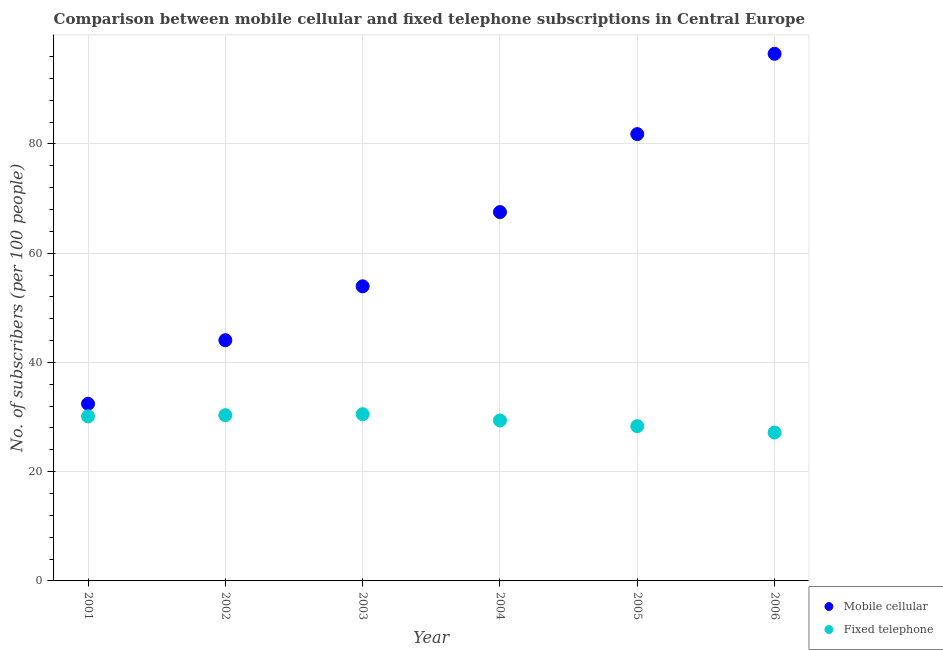Is the number of dotlines equal to the number of legend labels?
Offer a terse response. Yes. What is the number of fixed telephone subscribers in 2001?
Give a very brief answer. 30.13. Across all years, what is the maximum number of mobile cellular subscribers?
Your answer should be compact. 96.49. Across all years, what is the minimum number of fixed telephone subscribers?
Your answer should be compact. 27.16. In which year was the number of fixed telephone subscribers maximum?
Offer a terse response. 2003. In which year was the number of mobile cellular subscribers minimum?
Your answer should be very brief. 2001. What is the total number of fixed telephone subscribers in the graph?
Give a very brief answer. 175.86. What is the difference between the number of mobile cellular subscribers in 2001 and that in 2002?
Your answer should be compact. -11.64. What is the difference between the number of fixed telephone subscribers in 2001 and the number of mobile cellular subscribers in 2006?
Provide a succinct answer. -66.36. What is the average number of mobile cellular subscribers per year?
Provide a short and direct response. 62.71. In the year 2005, what is the difference between the number of fixed telephone subscribers and number of mobile cellular subscribers?
Make the answer very short. -53.47. What is the ratio of the number of mobile cellular subscribers in 2003 to that in 2004?
Ensure brevity in your answer.  0.8. Is the number of fixed telephone subscribers in 2002 less than that in 2004?
Keep it short and to the point. No. Is the difference between the number of mobile cellular subscribers in 2001 and 2005 greater than the difference between the number of fixed telephone subscribers in 2001 and 2005?
Your response must be concise. No. What is the difference between the highest and the second highest number of fixed telephone subscribers?
Offer a terse response. 0.18. What is the difference between the highest and the lowest number of fixed telephone subscribers?
Give a very brief answer. 3.36. In how many years, is the number of mobile cellular subscribers greater than the average number of mobile cellular subscribers taken over all years?
Your response must be concise. 3. Is the number of mobile cellular subscribers strictly greater than the number of fixed telephone subscribers over the years?
Provide a short and direct response. Yes. Is the number of fixed telephone subscribers strictly less than the number of mobile cellular subscribers over the years?
Give a very brief answer. Yes. How many years are there in the graph?
Provide a succinct answer. 6. Does the graph contain any zero values?
Provide a succinct answer. No. Where does the legend appear in the graph?
Ensure brevity in your answer.  Bottom right. How many legend labels are there?
Provide a short and direct response. 2. How are the legend labels stacked?
Your answer should be very brief. Vertical. What is the title of the graph?
Your response must be concise. Comparison between mobile cellular and fixed telephone subscriptions in Central Europe. What is the label or title of the Y-axis?
Ensure brevity in your answer.  No. of subscribers (per 100 people). What is the No. of subscribers (per 100 people) in Mobile cellular in 2001?
Provide a short and direct response. 32.43. What is the No. of subscribers (per 100 people) in Fixed telephone in 2001?
Offer a terse response. 30.13. What is the No. of subscribers (per 100 people) of Mobile cellular in 2002?
Keep it short and to the point. 44.07. What is the No. of subscribers (per 100 people) of Fixed telephone in 2002?
Your response must be concise. 30.34. What is the No. of subscribers (per 100 people) in Mobile cellular in 2003?
Offer a terse response. 53.93. What is the No. of subscribers (per 100 people) of Fixed telephone in 2003?
Keep it short and to the point. 30.52. What is the No. of subscribers (per 100 people) of Mobile cellular in 2004?
Make the answer very short. 67.52. What is the No. of subscribers (per 100 people) of Fixed telephone in 2004?
Your answer should be very brief. 29.37. What is the No. of subscribers (per 100 people) of Mobile cellular in 2005?
Your response must be concise. 81.8. What is the No. of subscribers (per 100 people) in Fixed telephone in 2005?
Offer a terse response. 28.33. What is the No. of subscribers (per 100 people) in Mobile cellular in 2006?
Make the answer very short. 96.49. What is the No. of subscribers (per 100 people) of Fixed telephone in 2006?
Offer a terse response. 27.16. Across all years, what is the maximum No. of subscribers (per 100 people) of Mobile cellular?
Keep it short and to the point. 96.49. Across all years, what is the maximum No. of subscribers (per 100 people) of Fixed telephone?
Your answer should be very brief. 30.52. Across all years, what is the minimum No. of subscribers (per 100 people) in Mobile cellular?
Offer a very short reply. 32.43. Across all years, what is the minimum No. of subscribers (per 100 people) of Fixed telephone?
Ensure brevity in your answer.  27.16. What is the total No. of subscribers (per 100 people) of Mobile cellular in the graph?
Ensure brevity in your answer.  376.24. What is the total No. of subscribers (per 100 people) in Fixed telephone in the graph?
Ensure brevity in your answer.  175.86. What is the difference between the No. of subscribers (per 100 people) of Mobile cellular in 2001 and that in 2002?
Make the answer very short. -11.64. What is the difference between the No. of subscribers (per 100 people) of Fixed telephone in 2001 and that in 2002?
Provide a short and direct response. -0.21. What is the difference between the No. of subscribers (per 100 people) in Mobile cellular in 2001 and that in 2003?
Give a very brief answer. -21.5. What is the difference between the No. of subscribers (per 100 people) in Fixed telephone in 2001 and that in 2003?
Provide a succinct answer. -0.39. What is the difference between the No. of subscribers (per 100 people) in Mobile cellular in 2001 and that in 2004?
Give a very brief answer. -35.09. What is the difference between the No. of subscribers (per 100 people) of Fixed telephone in 2001 and that in 2004?
Offer a very short reply. 0.75. What is the difference between the No. of subscribers (per 100 people) in Mobile cellular in 2001 and that in 2005?
Keep it short and to the point. -49.37. What is the difference between the No. of subscribers (per 100 people) of Fixed telephone in 2001 and that in 2005?
Provide a short and direct response. 1.8. What is the difference between the No. of subscribers (per 100 people) in Mobile cellular in 2001 and that in 2006?
Offer a very short reply. -64.07. What is the difference between the No. of subscribers (per 100 people) of Fixed telephone in 2001 and that in 2006?
Your answer should be very brief. 2.97. What is the difference between the No. of subscribers (per 100 people) in Mobile cellular in 2002 and that in 2003?
Provide a short and direct response. -9.86. What is the difference between the No. of subscribers (per 100 people) in Fixed telephone in 2002 and that in 2003?
Your response must be concise. -0.18. What is the difference between the No. of subscribers (per 100 people) of Mobile cellular in 2002 and that in 2004?
Your answer should be very brief. -23.45. What is the difference between the No. of subscribers (per 100 people) of Fixed telephone in 2002 and that in 2004?
Provide a succinct answer. 0.97. What is the difference between the No. of subscribers (per 100 people) of Mobile cellular in 2002 and that in 2005?
Keep it short and to the point. -37.73. What is the difference between the No. of subscribers (per 100 people) of Fixed telephone in 2002 and that in 2005?
Offer a terse response. 2.01. What is the difference between the No. of subscribers (per 100 people) of Mobile cellular in 2002 and that in 2006?
Offer a terse response. -52.43. What is the difference between the No. of subscribers (per 100 people) in Fixed telephone in 2002 and that in 2006?
Your response must be concise. 3.18. What is the difference between the No. of subscribers (per 100 people) in Mobile cellular in 2003 and that in 2004?
Your response must be concise. -13.59. What is the difference between the No. of subscribers (per 100 people) in Fixed telephone in 2003 and that in 2004?
Offer a very short reply. 1.15. What is the difference between the No. of subscribers (per 100 people) in Mobile cellular in 2003 and that in 2005?
Ensure brevity in your answer.  -27.87. What is the difference between the No. of subscribers (per 100 people) of Fixed telephone in 2003 and that in 2005?
Provide a short and direct response. 2.19. What is the difference between the No. of subscribers (per 100 people) in Mobile cellular in 2003 and that in 2006?
Provide a short and direct response. -42.56. What is the difference between the No. of subscribers (per 100 people) in Fixed telephone in 2003 and that in 2006?
Offer a very short reply. 3.36. What is the difference between the No. of subscribers (per 100 people) of Mobile cellular in 2004 and that in 2005?
Your answer should be compact. -14.28. What is the difference between the No. of subscribers (per 100 people) in Fixed telephone in 2004 and that in 2005?
Provide a short and direct response. 1.04. What is the difference between the No. of subscribers (per 100 people) in Mobile cellular in 2004 and that in 2006?
Your answer should be very brief. -28.97. What is the difference between the No. of subscribers (per 100 people) of Fixed telephone in 2004 and that in 2006?
Make the answer very short. 2.21. What is the difference between the No. of subscribers (per 100 people) of Mobile cellular in 2005 and that in 2006?
Provide a short and direct response. -14.7. What is the difference between the No. of subscribers (per 100 people) of Fixed telephone in 2005 and that in 2006?
Your answer should be very brief. 1.17. What is the difference between the No. of subscribers (per 100 people) of Mobile cellular in 2001 and the No. of subscribers (per 100 people) of Fixed telephone in 2002?
Your answer should be very brief. 2.08. What is the difference between the No. of subscribers (per 100 people) of Mobile cellular in 2001 and the No. of subscribers (per 100 people) of Fixed telephone in 2003?
Give a very brief answer. 1.9. What is the difference between the No. of subscribers (per 100 people) in Mobile cellular in 2001 and the No. of subscribers (per 100 people) in Fixed telephone in 2004?
Make the answer very short. 3.05. What is the difference between the No. of subscribers (per 100 people) of Mobile cellular in 2001 and the No. of subscribers (per 100 people) of Fixed telephone in 2005?
Offer a very short reply. 4.1. What is the difference between the No. of subscribers (per 100 people) of Mobile cellular in 2001 and the No. of subscribers (per 100 people) of Fixed telephone in 2006?
Your response must be concise. 5.27. What is the difference between the No. of subscribers (per 100 people) in Mobile cellular in 2002 and the No. of subscribers (per 100 people) in Fixed telephone in 2003?
Keep it short and to the point. 13.55. What is the difference between the No. of subscribers (per 100 people) of Mobile cellular in 2002 and the No. of subscribers (per 100 people) of Fixed telephone in 2004?
Provide a short and direct response. 14.69. What is the difference between the No. of subscribers (per 100 people) in Mobile cellular in 2002 and the No. of subscribers (per 100 people) in Fixed telephone in 2005?
Make the answer very short. 15.74. What is the difference between the No. of subscribers (per 100 people) in Mobile cellular in 2002 and the No. of subscribers (per 100 people) in Fixed telephone in 2006?
Your response must be concise. 16.91. What is the difference between the No. of subscribers (per 100 people) in Mobile cellular in 2003 and the No. of subscribers (per 100 people) in Fixed telephone in 2004?
Your response must be concise. 24.56. What is the difference between the No. of subscribers (per 100 people) of Mobile cellular in 2003 and the No. of subscribers (per 100 people) of Fixed telephone in 2005?
Your answer should be compact. 25.6. What is the difference between the No. of subscribers (per 100 people) in Mobile cellular in 2003 and the No. of subscribers (per 100 people) in Fixed telephone in 2006?
Offer a very short reply. 26.77. What is the difference between the No. of subscribers (per 100 people) of Mobile cellular in 2004 and the No. of subscribers (per 100 people) of Fixed telephone in 2005?
Offer a terse response. 39.19. What is the difference between the No. of subscribers (per 100 people) in Mobile cellular in 2004 and the No. of subscribers (per 100 people) in Fixed telephone in 2006?
Your answer should be compact. 40.36. What is the difference between the No. of subscribers (per 100 people) in Mobile cellular in 2005 and the No. of subscribers (per 100 people) in Fixed telephone in 2006?
Provide a short and direct response. 54.64. What is the average No. of subscribers (per 100 people) of Mobile cellular per year?
Give a very brief answer. 62.71. What is the average No. of subscribers (per 100 people) in Fixed telephone per year?
Provide a succinct answer. 29.31. In the year 2001, what is the difference between the No. of subscribers (per 100 people) in Mobile cellular and No. of subscribers (per 100 people) in Fixed telephone?
Your answer should be compact. 2.3. In the year 2002, what is the difference between the No. of subscribers (per 100 people) of Mobile cellular and No. of subscribers (per 100 people) of Fixed telephone?
Offer a terse response. 13.73. In the year 2003, what is the difference between the No. of subscribers (per 100 people) in Mobile cellular and No. of subscribers (per 100 people) in Fixed telephone?
Make the answer very short. 23.41. In the year 2004, what is the difference between the No. of subscribers (per 100 people) of Mobile cellular and No. of subscribers (per 100 people) of Fixed telephone?
Provide a short and direct response. 38.15. In the year 2005, what is the difference between the No. of subscribers (per 100 people) in Mobile cellular and No. of subscribers (per 100 people) in Fixed telephone?
Ensure brevity in your answer.  53.47. In the year 2006, what is the difference between the No. of subscribers (per 100 people) of Mobile cellular and No. of subscribers (per 100 people) of Fixed telephone?
Your answer should be very brief. 69.33. What is the ratio of the No. of subscribers (per 100 people) of Mobile cellular in 2001 to that in 2002?
Ensure brevity in your answer.  0.74. What is the ratio of the No. of subscribers (per 100 people) in Mobile cellular in 2001 to that in 2003?
Provide a succinct answer. 0.6. What is the ratio of the No. of subscribers (per 100 people) in Fixed telephone in 2001 to that in 2003?
Keep it short and to the point. 0.99. What is the ratio of the No. of subscribers (per 100 people) of Mobile cellular in 2001 to that in 2004?
Your response must be concise. 0.48. What is the ratio of the No. of subscribers (per 100 people) in Fixed telephone in 2001 to that in 2004?
Provide a short and direct response. 1.03. What is the ratio of the No. of subscribers (per 100 people) in Mobile cellular in 2001 to that in 2005?
Your response must be concise. 0.4. What is the ratio of the No. of subscribers (per 100 people) in Fixed telephone in 2001 to that in 2005?
Your answer should be very brief. 1.06. What is the ratio of the No. of subscribers (per 100 people) in Mobile cellular in 2001 to that in 2006?
Keep it short and to the point. 0.34. What is the ratio of the No. of subscribers (per 100 people) of Fixed telephone in 2001 to that in 2006?
Give a very brief answer. 1.11. What is the ratio of the No. of subscribers (per 100 people) of Mobile cellular in 2002 to that in 2003?
Ensure brevity in your answer.  0.82. What is the ratio of the No. of subscribers (per 100 people) in Mobile cellular in 2002 to that in 2004?
Give a very brief answer. 0.65. What is the ratio of the No. of subscribers (per 100 people) of Fixed telephone in 2002 to that in 2004?
Provide a succinct answer. 1.03. What is the ratio of the No. of subscribers (per 100 people) in Mobile cellular in 2002 to that in 2005?
Offer a very short reply. 0.54. What is the ratio of the No. of subscribers (per 100 people) in Fixed telephone in 2002 to that in 2005?
Keep it short and to the point. 1.07. What is the ratio of the No. of subscribers (per 100 people) in Mobile cellular in 2002 to that in 2006?
Ensure brevity in your answer.  0.46. What is the ratio of the No. of subscribers (per 100 people) in Fixed telephone in 2002 to that in 2006?
Your response must be concise. 1.12. What is the ratio of the No. of subscribers (per 100 people) in Mobile cellular in 2003 to that in 2004?
Offer a very short reply. 0.8. What is the ratio of the No. of subscribers (per 100 people) in Fixed telephone in 2003 to that in 2004?
Your answer should be compact. 1.04. What is the ratio of the No. of subscribers (per 100 people) in Mobile cellular in 2003 to that in 2005?
Offer a very short reply. 0.66. What is the ratio of the No. of subscribers (per 100 people) in Fixed telephone in 2003 to that in 2005?
Give a very brief answer. 1.08. What is the ratio of the No. of subscribers (per 100 people) in Mobile cellular in 2003 to that in 2006?
Give a very brief answer. 0.56. What is the ratio of the No. of subscribers (per 100 people) of Fixed telephone in 2003 to that in 2006?
Make the answer very short. 1.12. What is the ratio of the No. of subscribers (per 100 people) in Mobile cellular in 2004 to that in 2005?
Keep it short and to the point. 0.83. What is the ratio of the No. of subscribers (per 100 people) of Fixed telephone in 2004 to that in 2005?
Give a very brief answer. 1.04. What is the ratio of the No. of subscribers (per 100 people) in Mobile cellular in 2004 to that in 2006?
Keep it short and to the point. 0.7. What is the ratio of the No. of subscribers (per 100 people) in Fixed telephone in 2004 to that in 2006?
Provide a short and direct response. 1.08. What is the ratio of the No. of subscribers (per 100 people) in Mobile cellular in 2005 to that in 2006?
Give a very brief answer. 0.85. What is the ratio of the No. of subscribers (per 100 people) of Fixed telephone in 2005 to that in 2006?
Make the answer very short. 1.04. What is the difference between the highest and the second highest No. of subscribers (per 100 people) in Mobile cellular?
Your response must be concise. 14.7. What is the difference between the highest and the second highest No. of subscribers (per 100 people) of Fixed telephone?
Make the answer very short. 0.18. What is the difference between the highest and the lowest No. of subscribers (per 100 people) in Mobile cellular?
Ensure brevity in your answer.  64.07. What is the difference between the highest and the lowest No. of subscribers (per 100 people) in Fixed telephone?
Your answer should be compact. 3.36. 